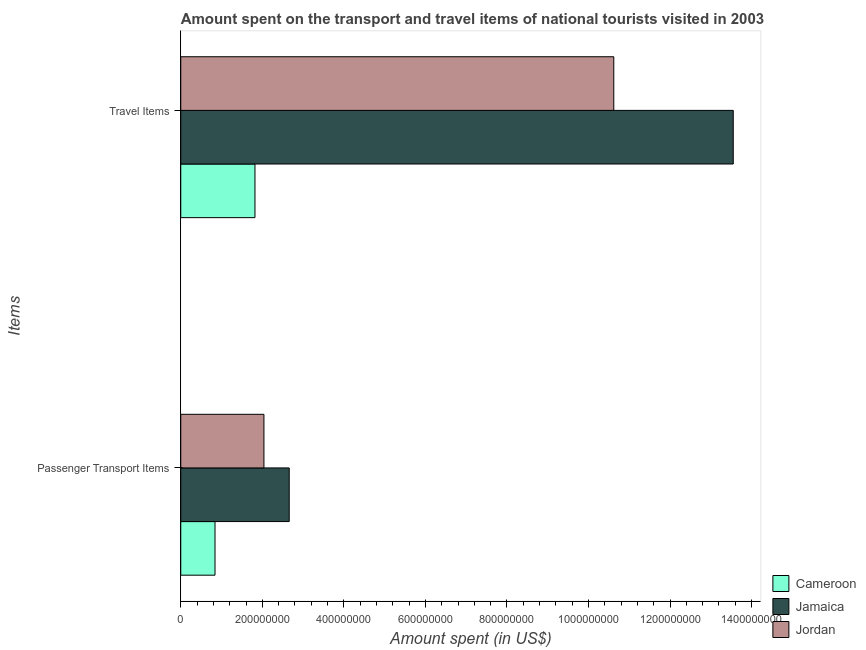How many groups of bars are there?
Make the answer very short. 2. Are the number of bars on each tick of the Y-axis equal?
Keep it short and to the point. Yes. What is the label of the 2nd group of bars from the top?
Give a very brief answer. Passenger Transport Items. What is the amount spent on passenger transport items in Jamaica?
Offer a very short reply. 2.66e+08. Across all countries, what is the maximum amount spent on passenger transport items?
Offer a terse response. 2.66e+08. Across all countries, what is the minimum amount spent in travel items?
Ensure brevity in your answer.  1.82e+08. In which country was the amount spent in travel items maximum?
Provide a succinct answer. Jamaica. In which country was the amount spent in travel items minimum?
Provide a short and direct response. Cameroon. What is the total amount spent in travel items in the graph?
Make the answer very short. 2.60e+09. What is the difference between the amount spent in travel items in Jamaica and that in Cameroon?
Keep it short and to the point. 1.17e+09. What is the difference between the amount spent on passenger transport items in Cameroon and the amount spent in travel items in Jamaica?
Keep it short and to the point. -1.27e+09. What is the average amount spent on passenger transport items per country?
Provide a short and direct response. 1.85e+08. What is the difference between the amount spent on passenger transport items and amount spent in travel items in Jamaica?
Give a very brief answer. -1.09e+09. What is the ratio of the amount spent in travel items in Cameroon to that in Jamaica?
Ensure brevity in your answer.  0.13. Is the amount spent on passenger transport items in Jamaica less than that in Jordan?
Your answer should be compact. No. What does the 2nd bar from the top in Travel Items represents?
Make the answer very short. Jamaica. What does the 1st bar from the bottom in Travel Items represents?
Your answer should be very brief. Cameroon. What is the difference between two consecutive major ticks on the X-axis?
Your answer should be compact. 2.00e+08. Are the values on the major ticks of X-axis written in scientific E-notation?
Provide a succinct answer. No. Does the graph contain any zero values?
Offer a terse response. No. How are the legend labels stacked?
Offer a very short reply. Vertical. What is the title of the graph?
Offer a very short reply. Amount spent on the transport and travel items of national tourists visited in 2003. What is the label or title of the X-axis?
Your answer should be very brief. Amount spent (in US$). What is the label or title of the Y-axis?
Keep it short and to the point. Items. What is the Amount spent (in US$) of Cameroon in Passenger Transport Items?
Provide a succinct answer. 8.40e+07. What is the Amount spent (in US$) in Jamaica in Passenger Transport Items?
Offer a very short reply. 2.66e+08. What is the Amount spent (in US$) in Jordan in Passenger Transport Items?
Offer a very short reply. 2.04e+08. What is the Amount spent (in US$) of Cameroon in Travel Items?
Make the answer very short. 1.82e+08. What is the Amount spent (in US$) in Jamaica in Travel Items?
Provide a succinct answer. 1.36e+09. What is the Amount spent (in US$) of Jordan in Travel Items?
Provide a succinct answer. 1.06e+09. Across all Items, what is the maximum Amount spent (in US$) of Cameroon?
Offer a very short reply. 1.82e+08. Across all Items, what is the maximum Amount spent (in US$) of Jamaica?
Provide a succinct answer. 1.36e+09. Across all Items, what is the maximum Amount spent (in US$) of Jordan?
Your response must be concise. 1.06e+09. Across all Items, what is the minimum Amount spent (in US$) of Cameroon?
Your answer should be very brief. 8.40e+07. Across all Items, what is the minimum Amount spent (in US$) of Jamaica?
Provide a short and direct response. 2.66e+08. Across all Items, what is the minimum Amount spent (in US$) of Jordan?
Provide a succinct answer. 2.04e+08. What is the total Amount spent (in US$) in Cameroon in the graph?
Make the answer very short. 2.66e+08. What is the total Amount spent (in US$) in Jamaica in the graph?
Provide a short and direct response. 1.62e+09. What is the total Amount spent (in US$) of Jordan in the graph?
Offer a very short reply. 1.27e+09. What is the difference between the Amount spent (in US$) of Cameroon in Passenger Transport Items and that in Travel Items?
Give a very brief answer. -9.80e+07. What is the difference between the Amount spent (in US$) of Jamaica in Passenger Transport Items and that in Travel Items?
Provide a short and direct response. -1.09e+09. What is the difference between the Amount spent (in US$) in Jordan in Passenger Transport Items and that in Travel Items?
Provide a short and direct response. -8.58e+08. What is the difference between the Amount spent (in US$) of Cameroon in Passenger Transport Items and the Amount spent (in US$) of Jamaica in Travel Items?
Give a very brief answer. -1.27e+09. What is the difference between the Amount spent (in US$) of Cameroon in Passenger Transport Items and the Amount spent (in US$) of Jordan in Travel Items?
Ensure brevity in your answer.  -9.78e+08. What is the difference between the Amount spent (in US$) of Jamaica in Passenger Transport Items and the Amount spent (in US$) of Jordan in Travel Items?
Provide a short and direct response. -7.96e+08. What is the average Amount spent (in US$) of Cameroon per Items?
Offer a very short reply. 1.33e+08. What is the average Amount spent (in US$) in Jamaica per Items?
Your answer should be compact. 8.10e+08. What is the average Amount spent (in US$) of Jordan per Items?
Offer a very short reply. 6.33e+08. What is the difference between the Amount spent (in US$) in Cameroon and Amount spent (in US$) in Jamaica in Passenger Transport Items?
Offer a very short reply. -1.82e+08. What is the difference between the Amount spent (in US$) in Cameroon and Amount spent (in US$) in Jordan in Passenger Transport Items?
Provide a short and direct response. -1.20e+08. What is the difference between the Amount spent (in US$) in Jamaica and Amount spent (in US$) in Jordan in Passenger Transport Items?
Your answer should be very brief. 6.20e+07. What is the difference between the Amount spent (in US$) in Cameroon and Amount spent (in US$) in Jamaica in Travel Items?
Make the answer very short. -1.17e+09. What is the difference between the Amount spent (in US$) in Cameroon and Amount spent (in US$) in Jordan in Travel Items?
Ensure brevity in your answer.  -8.80e+08. What is the difference between the Amount spent (in US$) of Jamaica and Amount spent (in US$) of Jordan in Travel Items?
Your answer should be very brief. 2.93e+08. What is the ratio of the Amount spent (in US$) of Cameroon in Passenger Transport Items to that in Travel Items?
Ensure brevity in your answer.  0.46. What is the ratio of the Amount spent (in US$) of Jamaica in Passenger Transport Items to that in Travel Items?
Provide a short and direct response. 0.2. What is the ratio of the Amount spent (in US$) of Jordan in Passenger Transport Items to that in Travel Items?
Your answer should be compact. 0.19. What is the difference between the highest and the second highest Amount spent (in US$) of Cameroon?
Your answer should be compact. 9.80e+07. What is the difference between the highest and the second highest Amount spent (in US$) of Jamaica?
Provide a succinct answer. 1.09e+09. What is the difference between the highest and the second highest Amount spent (in US$) of Jordan?
Make the answer very short. 8.58e+08. What is the difference between the highest and the lowest Amount spent (in US$) of Cameroon?
Offer a terse response. 9.80e+07. What is the difference between the highest and the lowest Amount spent (in US$) in Jamaica?
Your answer should be very brief. 1.09e+09. What is the difference between the highest and the lowest Amount spent (in US$) in Jordan?
Make the answer very short. 8.58e+08. 